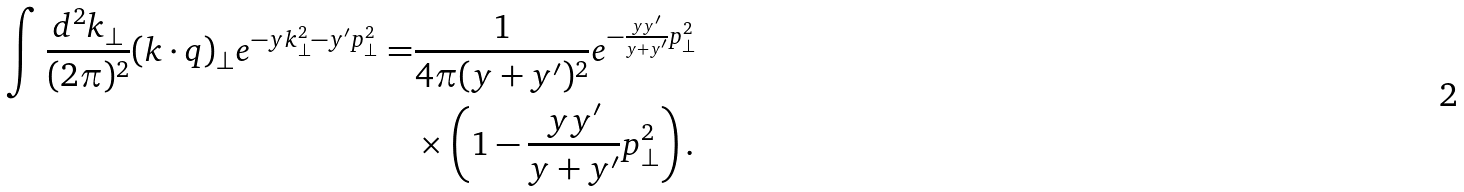<formula> <loc_0><loc_0><loc_500><loc_500>\int \frac { d ^ { 2 } { k } _ { \perp } } { ( 2 \pi ) ^ { 2 } } ( { k } \cdot { q } ) _ { \perp } e ^ { - y { k } _ { \perp } ^ { 2 } - y ^ { \prime } { p } _ { \perp } ^ { 2 } } = & \frac { 1 } { 4 \pi ( y + y ^ { \prime } ) ^ { 2 } } e ^ { - \frac { y y ^ { \prime } } { y + y ^ { \prime } } { p } _ { \perp } ^ { 2 } } \\ & \times \left ( 1 - \frac { y y ^ { \prime } } { y + y ^ { \prime } } { p } _ { \perp } ^ { 2 } \right ) .</formula> 